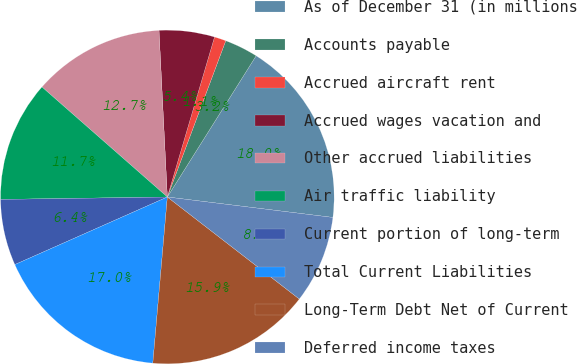Convert chart to OTSL. <chart><loc_0><loc_0><loc_500><loc_500><pie_chart><fcel>As of December 31 (in millions<fcel>Accounts payable<fcel>Accrued aircraft rent<fcel>Accrued wages vacation and<fcel>Other accrued liabilities<fcel>Air traffic liability<fcel>Current portion of long-term<fcel>Total Current Liabilities<fcel>Long-Term Debt Net of Current<fcel>Deferred income taxes<nl><fcel>18.02%<fcel>3.24%<fcel>1.13%<fcel>5.36%<fcel>12.74%<fcel>11.69%<fcel>6.41%<fcel>16.97%<fcel>15.91%<fcel>8.52%<nl></chart> 